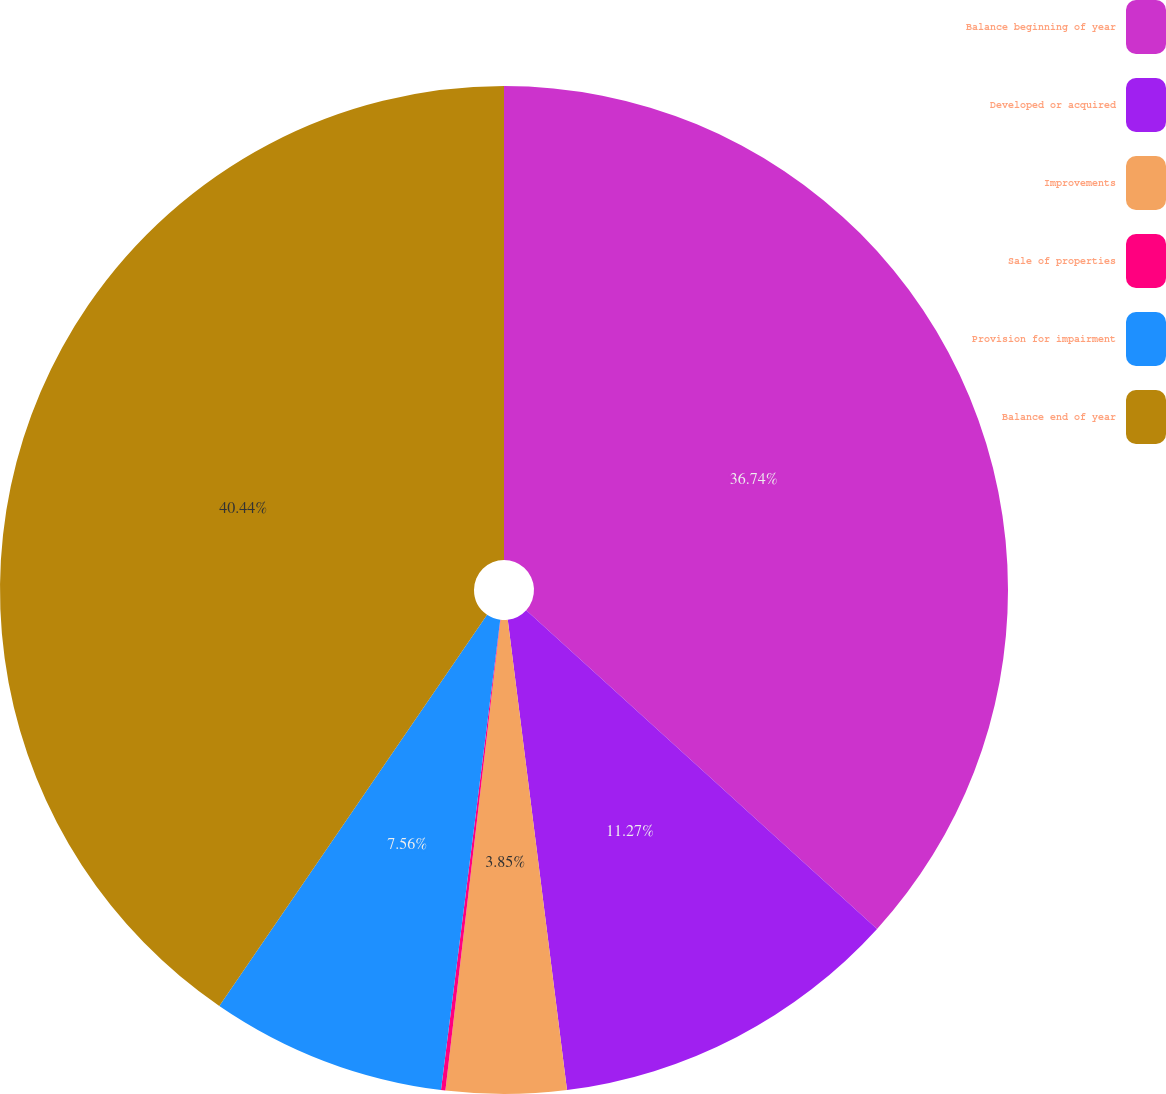Convert chart. <chart><loc_0><loc_0><loc_500><loc_500><pie_chart><fcel>Balance beginning of year<fcel>Developed or acquired<fcel>Improvements<fcel>Sale of properties<fcel>Provision for impairment<fcel>Balance end of year<nl><fcel>36.74%<fcel>11.27%<fcel>3.85%<fcel>0.14%<fcel>7.56%<fcel>40.45%<nl></chart> 